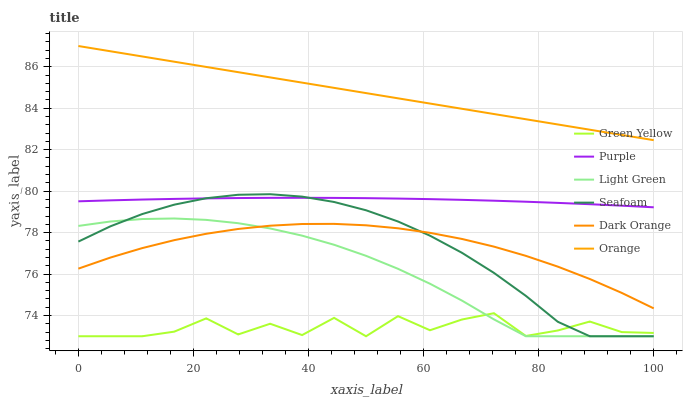Does Green Yellow have the minimum area under the curve?
Answer yes or no. Yes. Does Orange have the maximum area under the curve?
Answer yes or no. Yes. Does Purple have the minimum area under the curve?
Answer yes or no. No. Does Purple have the maximum area under the curve?
Answer yes or no. No. Is Orange the smoothest?
Answer yes or no. Yes. Is Green Yellow the roughest?
Answer yes or no. Yes. Is Purple the smoothest?
Answer yes or no. No. Is Purple the roughest?
Answer yes or no. No. Does Seafoam have the lowest value?
Answer yes or no. Yes. Does Purple have the lowest value?
Answer yes or no. No. Does Orange have the highest value?
Answer yes or no. Yes. Does Purple have the highest value?
Answer yes or no. No. Is Dark Orange less than Orange?
Answer yes or no. Yes. Is Orange greater than Light Green?
Answer yes or no. Yes. Does Light Green intersect Green Yellow?
Answer yes or no. Yes. Is Light Green less than Green Yellow?
Answer yes or no. No. Is Light Green greater than Green Yellow?
Answer yes or no. No. Does Dark Orange intersect Orange?
Answer yes or no. No. 